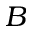Convert formula to latex. <formula><loc_0><loc_0><loc_500><loc_500>B</formula> 